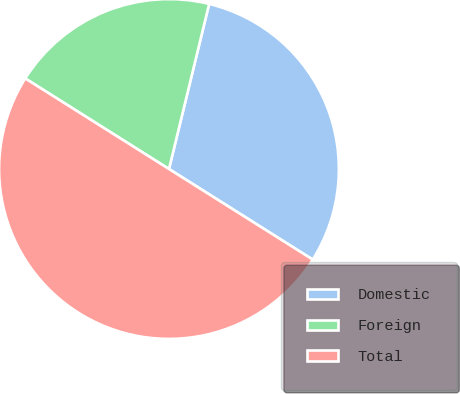Convert chart to OTSL. <chart><loc_0><loc_0><loc_500><loc_500><pie_chart><fcel>Domestic<fcel>Foreign<fcel>Total<nl><fcel>30.15%<fcel>19.85%<fcel>50.0%<nl></chart> 